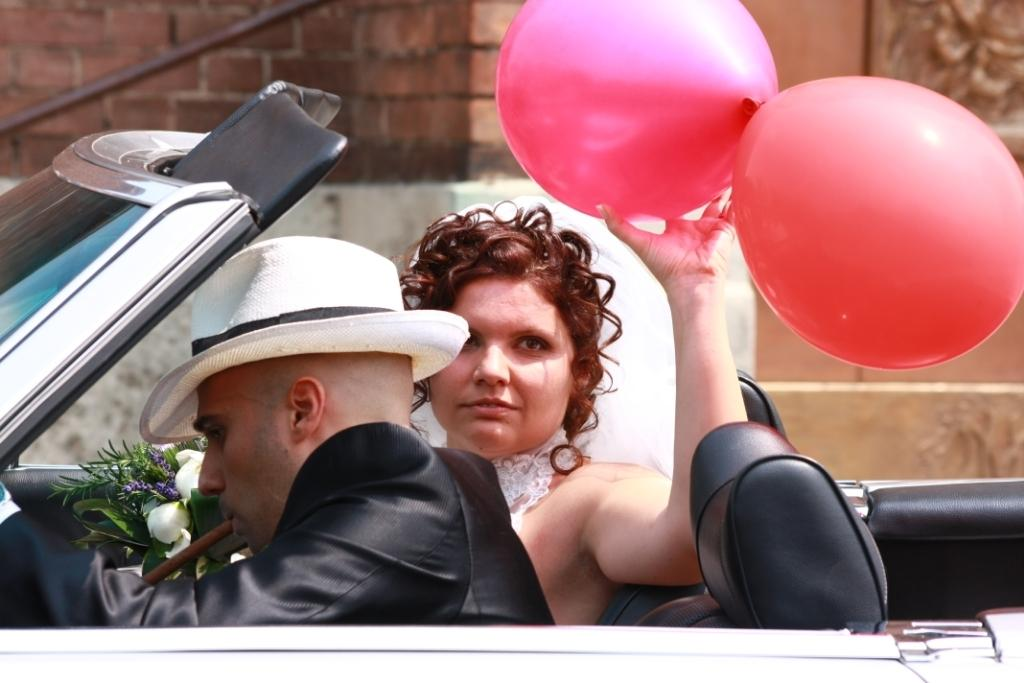How many people are in the vehicle in the image? There are two persons sitting in the vehicle in the image. What is one of the persons holding? One person is holding balloons. What other object can be seen in the image? There is a flower bouquet. What is visible in the background of the image? There is a wall in the background of the image. In which direction are the persons in the vehicle jumping in the image? There is no indication in the image that the persons in the vehicle are jumping. --- Facts: 1. There is a person holding a camera. 2. The person is standing on a bridge. 3. There is a river below the bridge. 4. The sky is visible in the image. Absurd Topics: dance, book, bird Conversation: What is the person in the image holding? The person in the image is holding a camera. Where is the person standing in the image? The person is standing on a bridge. What can be seen below the bridge in the image? There is a river below the bridge. What is visible in the background of the image? The sky is visible in the image. Reasoning: Let's think step by step in order to produce the conversation. We start by identifying the main subject in the image, which is the person holding a camera. Then, we describe where the person is standing, which is on a bridge. Next, we mention what can be seen below the bridge, which is a river. Finally, we describe the background of the image, which includes the sky. Absurd Question/Answer: What type of book is the person reading while standing on the bridge in the image? There is no book present in the image; the person is holding a camera. 